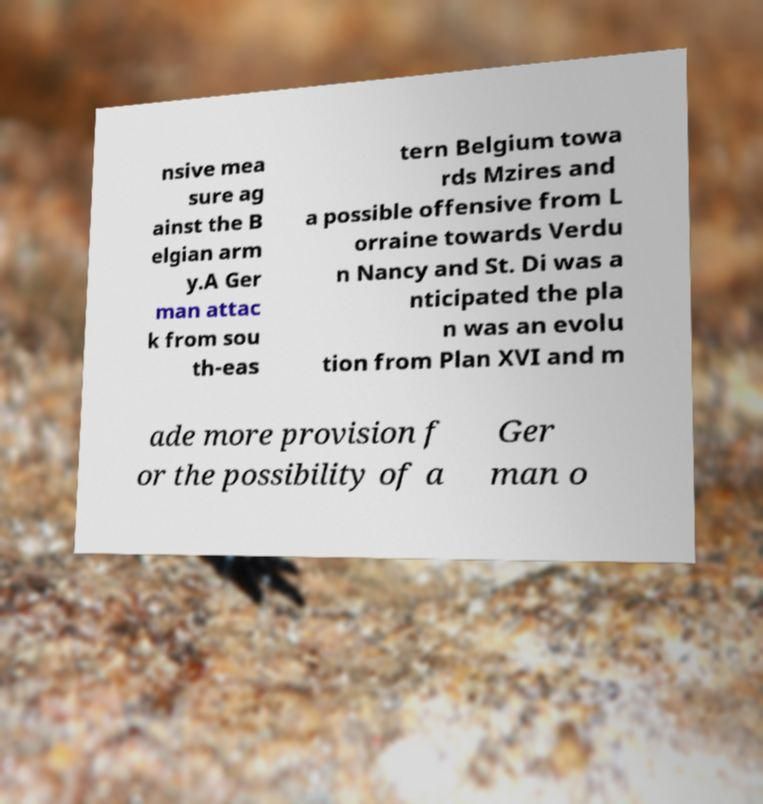Could you assist in decoding the text presented in this image and type it out clearly? nsive mea sure ag ainst the B elgian arm y.A Ger man attac k from sou th-eas tern Belgium towa rds Mzires and a possible offensive from L orraine towards Verdu n Nancy and St. Di was a nticipated the pla n was an evolu tion from Plan XVI and m ade more provision f or the possibility of a Ger man o 